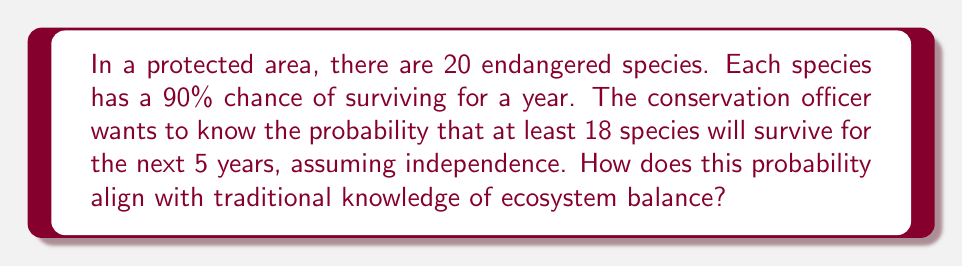Can you answer this question? Let's approach this step-by-step:

1) First, we need to calculate the probability of a single species surviving for 5 years:
   $P(\text{survive 5 years}) = (0.9)^5 = 0.59049$

2) Now, we can model this as a binomial distribution. We want the probability of 18, 19, or 20 species surviving out of 20.

3) The probability mass function for a binomial distribution is:
   $$P(X = k) = \binom{n}{k} p^k (1-p)^{n-k}$$
   where $n = 20$, $p = 0.59049$, and $k = 18, 19, 20$

4) Let's calculate each probability:

   For $k = 18$:
   $$P(X = 18) = \binom{20}{18} (0.59049)^{18} (1-0.59049)^2 = 0.1840$$

   For $k = 19$:
   $$P(X = 19) = \binom{20}{19} (0.59049)^{19} (1-0.59049)^1 = 0.0702$$

   For $k = 20$:
   $$P(X = 20) = \binom{20}{20} (0.59049)^{20} (1-0.59049)^0 = 0.0067$$

5) The probability of at least 18 species surviving is the sum of these probabilities:
   $$P(X \geq 18) = 0.1840 + 0.0702 + 0.0067 = 0.2609$$

6) Therefore, there is approximately a 26.09% chance that at least 18 species will survive for the next 5 years.

This probability reflects the delicate balance in ecosystems. Traditional knowledge often emphasizes the interconnectedness of species and the importance of maintaining biodiversity. The relatively low probability (26.09%) aligns with the traditional understanding that ecosystems are fragile and require careful stewardship to maintain balance over time.
Answer: 0.2609 or 26.09% 